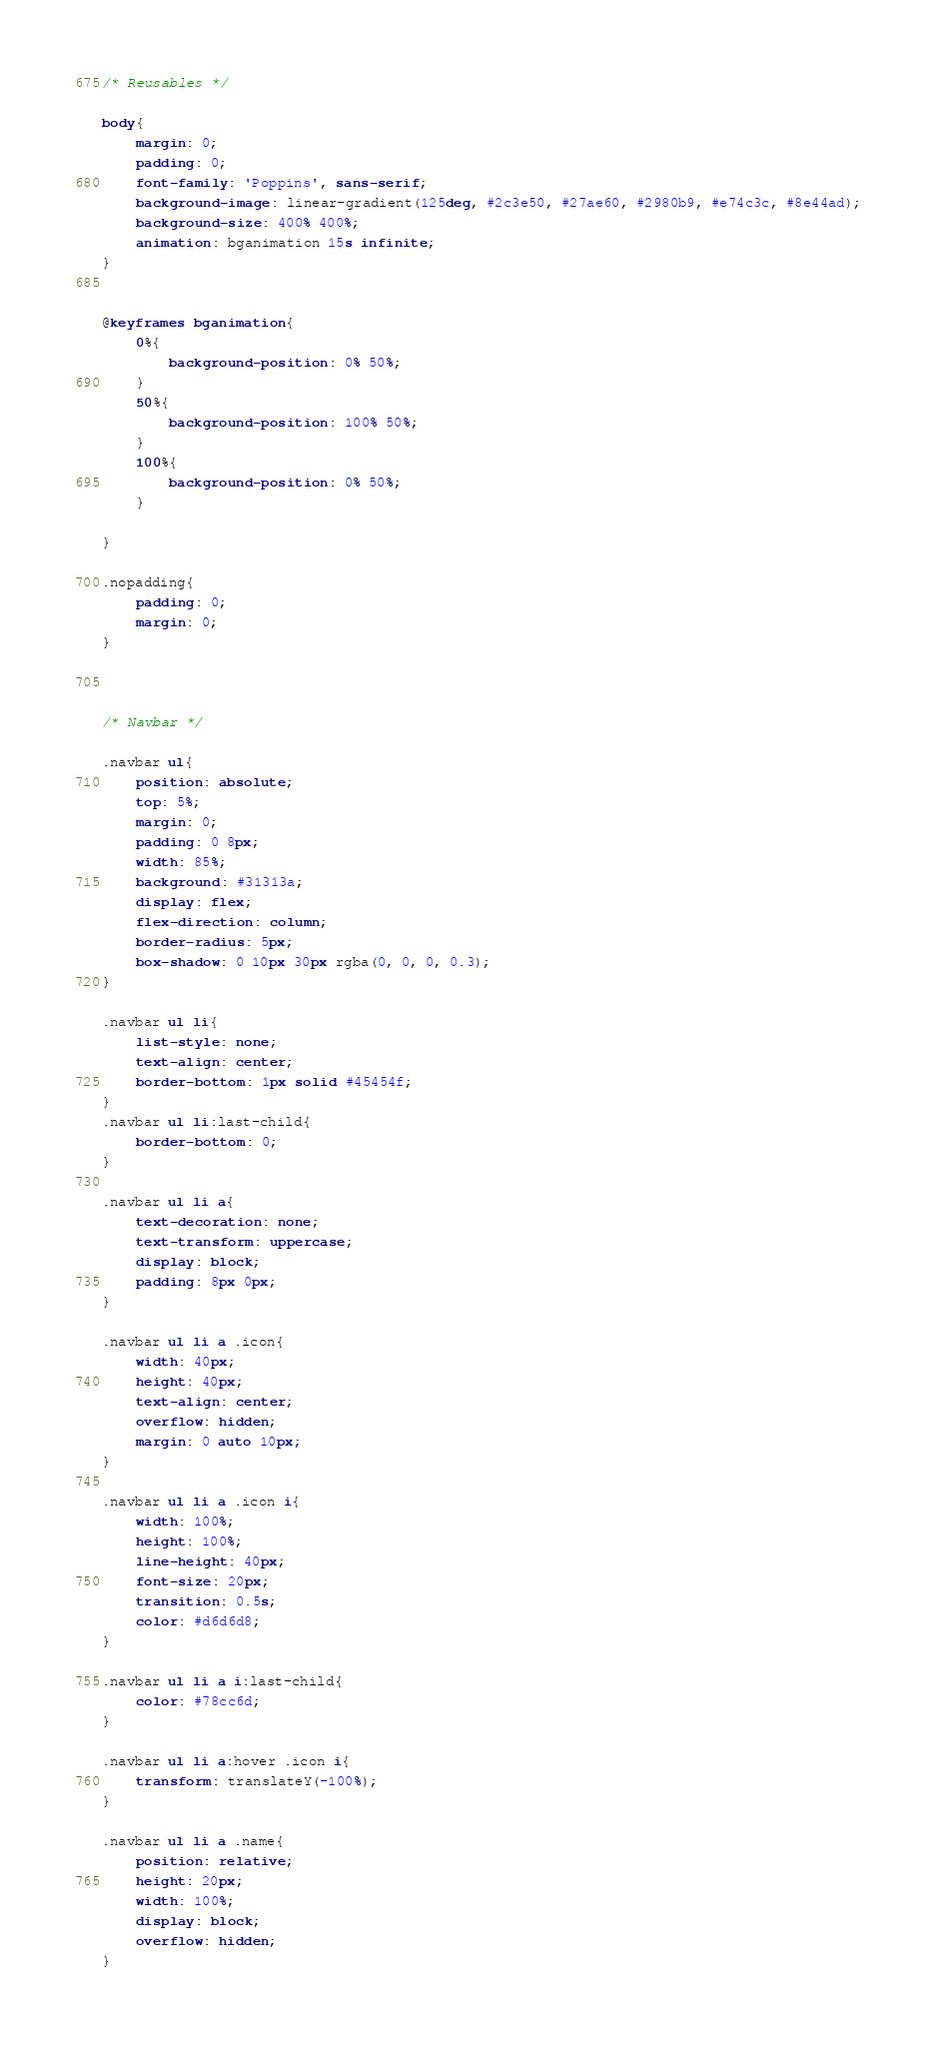Convert code to text. <code><loc_0><loc_0><loc_500><loc_500><_CSS_>/* Reusables */

body{
	margin: 0;
	padding: 0;
	font-family: 'Poppins', sans-serif;
	background-image: linear-gradient(125deg, #2c3e50, #27ae60, #2980b9, #e74c3c, #8e44ad);
	background-size: 400% 400%;
    animation: bganimation 15s infinite;
}


@keyframes bganimation{
	0%{
		background-position: 0% 50%;
	}
	50%{
		background-position: 100% 50%;
	}
	100%{
		background-position: 0% 50%;
	}

}

.nopadding{
    padding: 0;
    margin: 0;
}



/* Navbar */

.navbar ul{
    position: absolute;
    top: 5%;
    margin: 0;
    padding: 0 8px;
    width: 85%;
    background: #31313a;
    display: flex;
    flex-direction: column;
    border-radius: 5px;
    box-shadow: 0 10px 30px rgba(0, 0, 0, 0.3);
}

.navbar ul li{
    list-style: none;
    text-align: center;
    border-bottom: 1px solid #45454f;
}
.navbar ul li:last-child{
    border-bottom: 0;
}

.navbar ul li a{
    text-decoration: none;
    text-transform: uppercase;
    display: block;
    padding: 8px 0px;
}

.navbar ul li a .icon{
    width: 40px;
    height: 40px;
    text-align: center;
    overflow: hidden;
    margin: 0 auto 10px;
}

.navbar ul li a .icon i{
    width: 100%;
    height: 100%;
    line-height: 40px;
    font-size: 20px;
    transition: 0.5s;
    color: #d6d6d8;
}

.navbar ul li a i:last-child{
    color: #78cc6d;
}

.navbar ul li a:hover .icon i{
    transform: translateY(-100%);
}

.navbar ul li a .name{
    position: relative;
    height: 20px;
    width: 100%;
    display: block;
    overflow: hidden;
}
</code> 